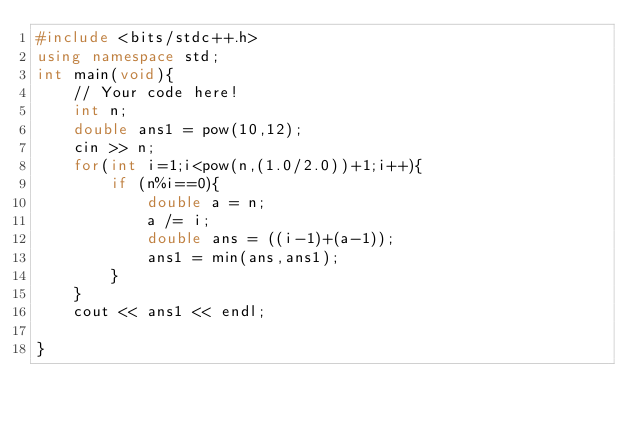Convert code to text. <code><loc_0><loc_0><loc_500><loc_500><_C++_>#include <bits/stdc++.h>
using namespace std;
int main(void){
    // Your code here!
    int n;
    double ans1 = pow(10,12);
    cin >> n;
    for(int i=1;i<pow(n,(1.0/2.0))+1;i++){
        if (n%i==0){
            double a = n;
            a /= i;
            double ans = ((i-1)+(a-1));
            ans1 = min(ans,ans1);
        }
    }
    cout << ans1 << endl;
    
} </code> 